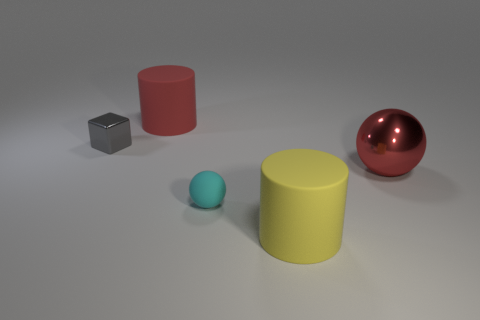What is the material of the large object that is to the left of the red metal ball and to the right of the red matte cylinder?
Keep it short and to the point. Rubber. Are there any large green objects?
Keep it short and to the point. No. There is a small cyan object that is made of the same material as the big yellow cylinder; what shape is it?
Offer a very short reply. Sphere. Do the tiny gray thing and the rubber thing that is on the right side of the tiny cyan sphere have the same shape?
Your response must be concise. No. What is the material of the cylinder in front of the rubber cylinder that is left of the cyan ball?
Keep it short and to the point. Rubber. What number of other things are there of the same shape as the large metal object?
Keep it short and to the point. 1. There is a yellow rubber object that is to the right of the tiny cyan matte object; does it have the same shape as the tiny object that is in front of the big metallic ball?
Your answer should be very brief. No. What is the small cyan object made of?
Give a very brief answer. Rubber. There is a ball that is left of the large metal object; what is its material?
Make the answer very short. Rubber. Is there any other thing of the same color as the tiny rubber sphere?
Your answer should be compact. No. 